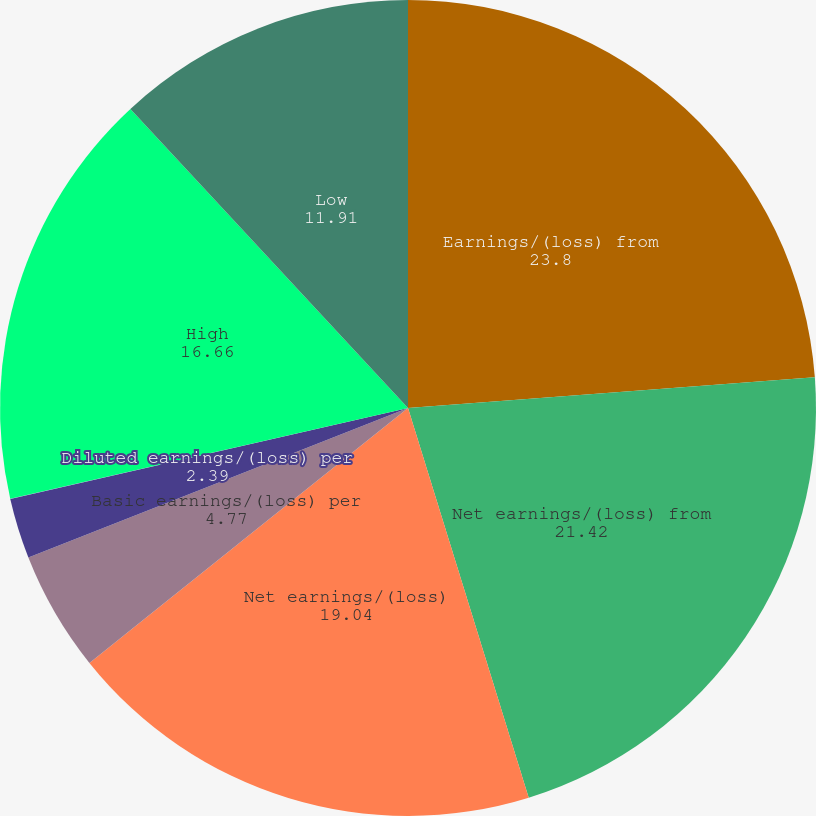<chart> <loc_0><loc_0><loc_500><loc_500><pie_chart><fcel>Earnings/(loss) from<fcel>Net earnings/(loss) from<fcel>Net earnings/(loss)<fcel>Basic earnings/(loss) per<fcel>Diluted earnings/(loss) per<fcel>Cash dividends paid per share<fcel>High<fcel>Low<nl><fcel>23.8%<fcel>21.42%<fcel>19.04%<fcel>4.77%<fcel>2.39%<fcel>0.01%<fcel>16.66%<fcel>11.91%<nl></chart> 